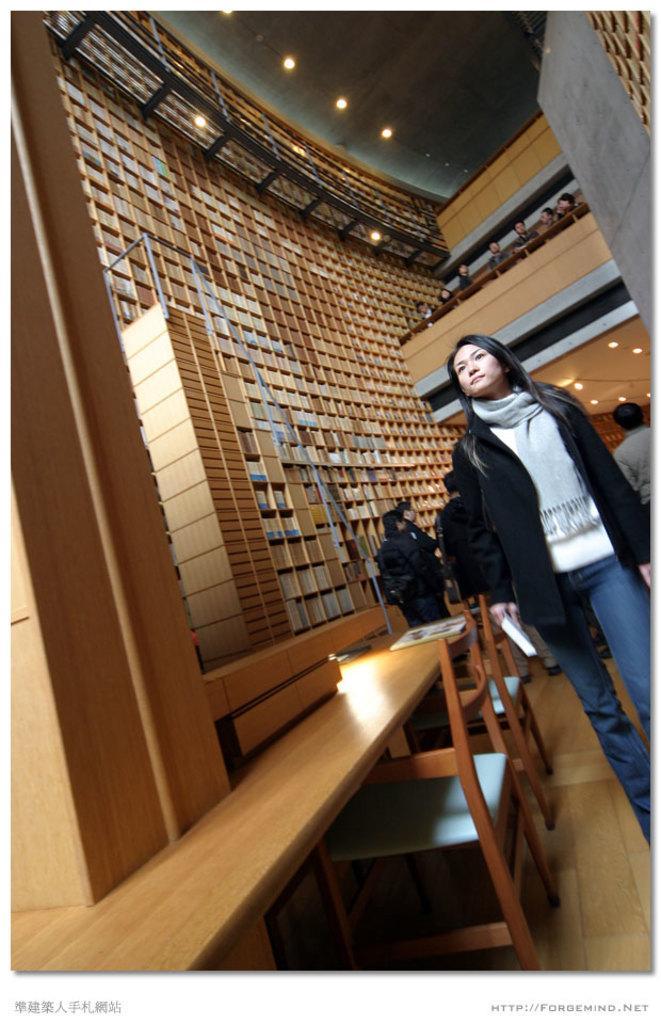How would you summarize this image in a sentence or two? In this picture we can see there are groups of people standing. On the left side of the women there are chairs and a table. On the left side of the people, those are looking like books in the racks. At the top there are ceiling lights. On the image there are watermarks. 